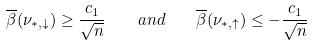<formula> <loc_0><loc_0><loc_500><loc_500>\overline { \beta } ( \nu _ { \ast , \downarrow } ) \geq \frac { c _ { 1 } } { \sqrt { n } } \quad a n d \quad \overline { \beta } ( \nu _ { \ast , \uparrow } ) \leq - \frac { c _ { 1 } } { \sqrt { n } }</formula> 